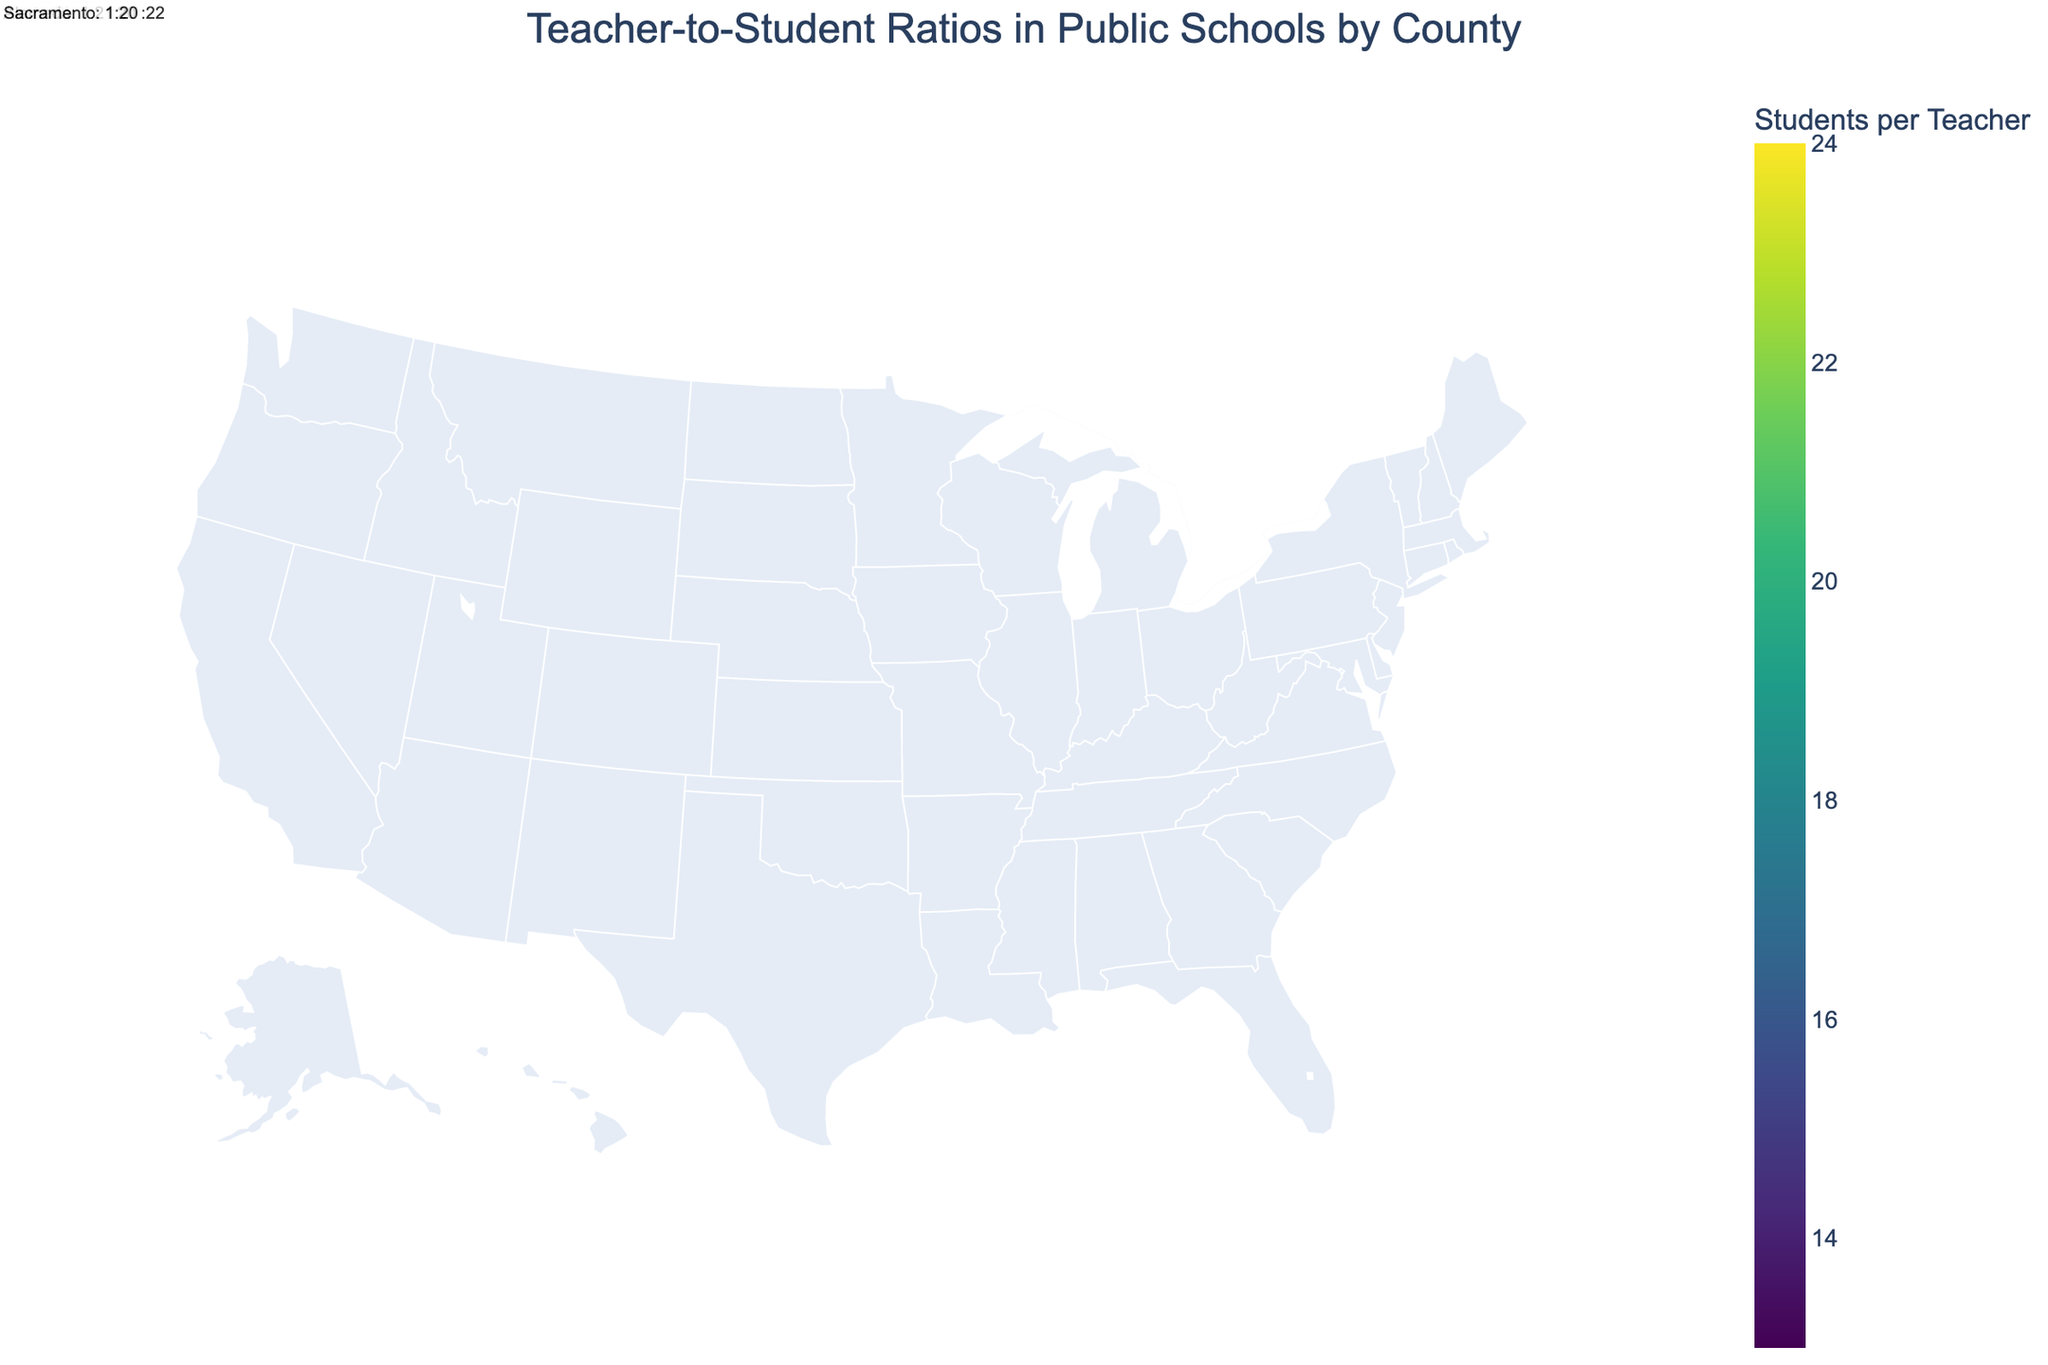Which county in California has the highest teacher-to-student ratio? By looking at the color intensities and text annotations for Californian counties, the ratios are identified. Orange County has a ratio of 1:24, which is the highest among Californian counties.
Answer: Orange County What is the teacher-to-student ratio in Dallas, Texas? By locating Texas on the map and finding Dallas, we read the text annotation that shows the teacher-to-student ratio. The ratio is 1:14.
Answer: 1:14 Which state has the widest range of teacher-to-student ratios across its counties? The map color can indicate the widest range by showing different intensities for counties within a state. California has counties ranging from 1:20 to 1:24, making it the state with the widest range.
Answer: California What is the average teacher-to-student ratio for counties in Florida? Florida counties (Miami-Dade and Broward) have ratios of 1:16 each. Averaging these ratios: (16 + 16) / 2 = 16.
Answer: 1:16 How many counties in Texas have a teacher-to-student ratio of 1:15? Texas counties with 1:15 ratio are identified by their color and annotations. Harris, Tarrant, and Bexar counties all have 1:15 ratios. Counting these gives 3.
Answer: 3 counties Which county has the lowest teacher-to-student ratio among all listed counties? The map shows varying color intensities, and reading the annotations determines that Kings County, New York, has the lowest ratio of 1:13.
Answer: Kings County Is Sacramento County's teacher-to-student ratio higher or lower than the ratio in Washington? By comparing the colors and annotations for Sacramento County, California, and King County, Washington, we find Sacramento has a ratio of 1:20 compared to Washington's 1:18, making Sacramento's ratio higher.
Answer: Higher What is the difference in teacher-to-student ratios between Cook County, Illinois, and Harris County, Texas? The ratios for Cook (1:16) and Harris (1:15) are read from their respective annotations. The difference is calculated as 16 - 15 = 1.
Answer: 1 Across all counties, what is the common teacher-to-student ratio visible in multiple states? By observing the map and identifying repeated colors and ratios in different states, the common ratio identified is 1:16.
Answer: 1:16 Which state appears to have a relatively uniform teacher-to-student ratio across its counties? By assessing the map’s color uniformity and annotated ratios per county in a state, Texas shows remarkable consistency with most counties having ratios around 1:15 or 1:14.
Answer: Texas 